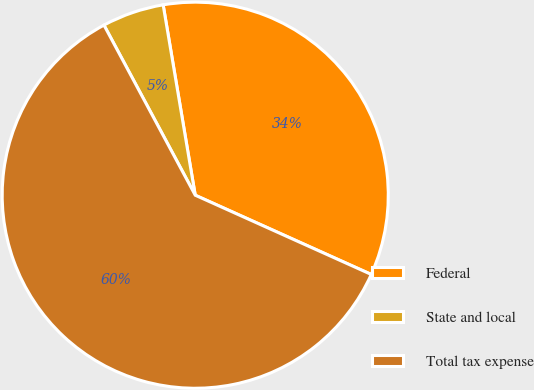<chart> <loc_0><loc_0><loc_500><loc_500><pie_chart><fcel>Federal<fcel>State and local<fcel>Total tax expense<nl><fcel>34.39%<fcel>5.18%<fcel>60.43%<nl></chart> 